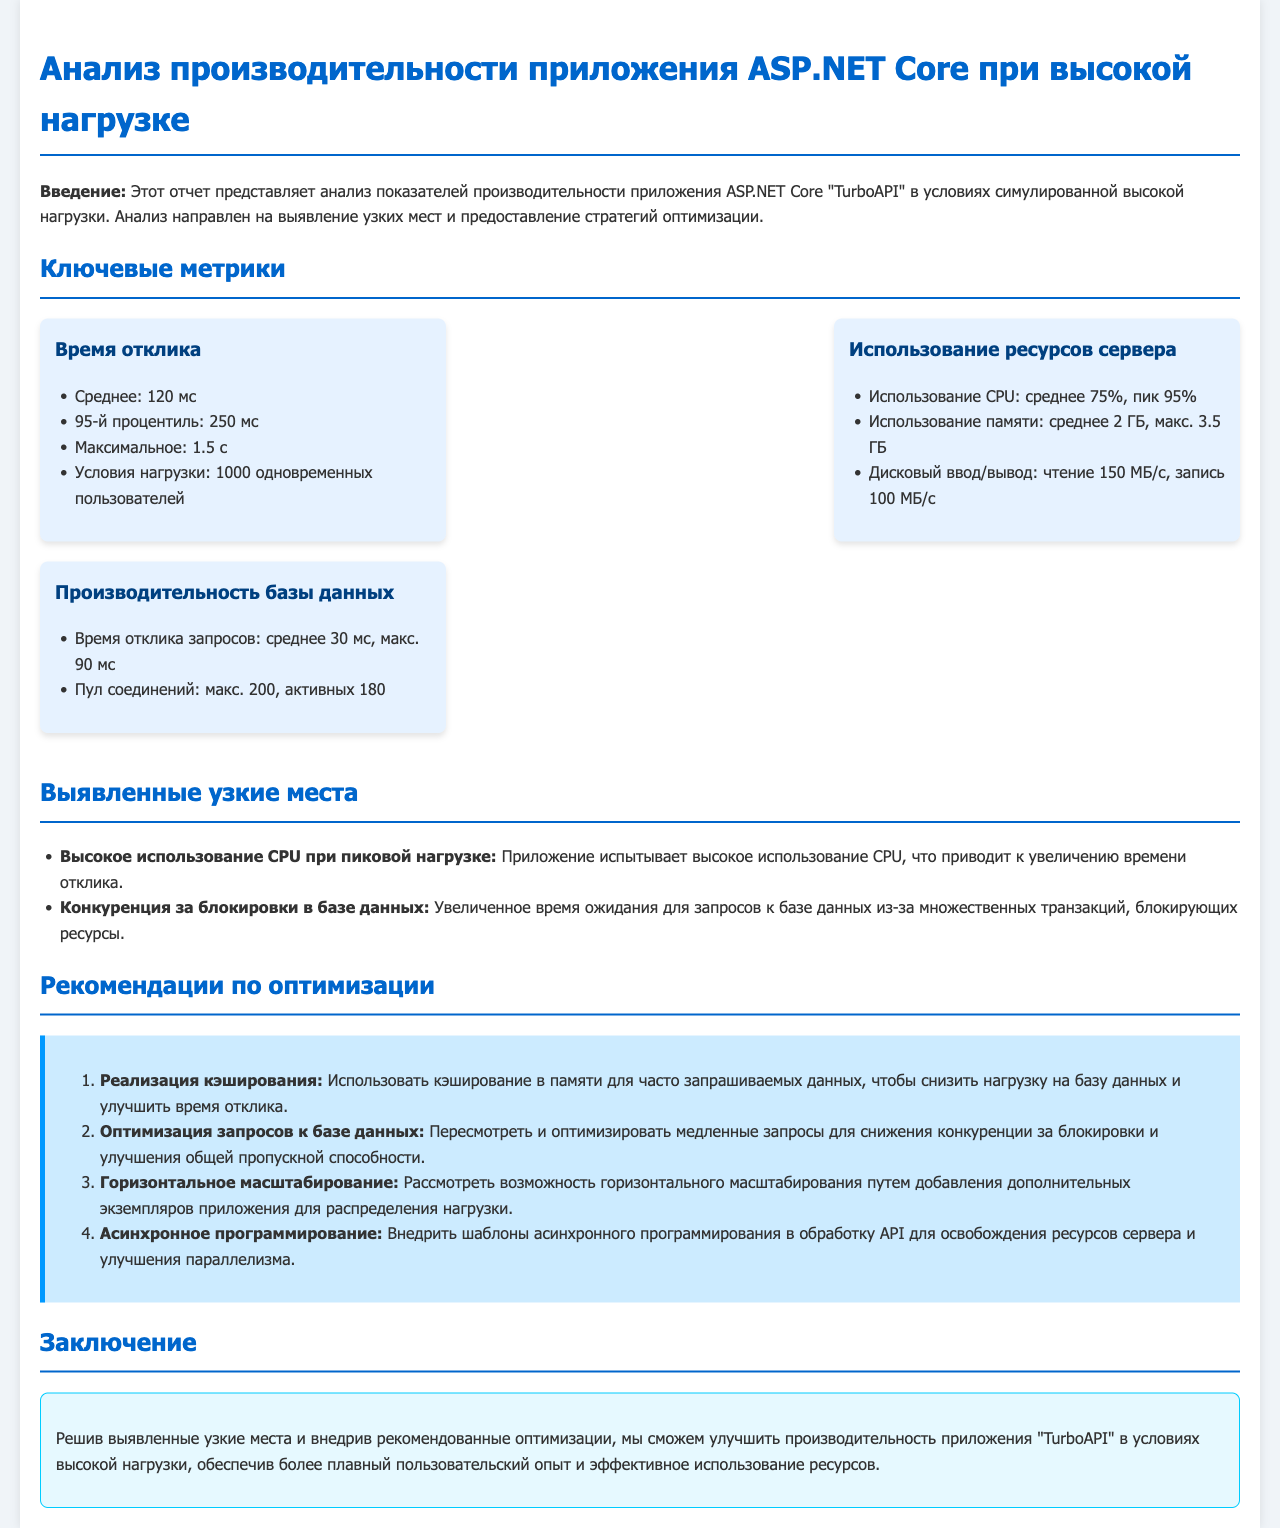что является средним временем отклика? Среднее время отклика указано в разделе ключевых метрик как 120 мс.
Answer: 120 мс какова максимальная загрузка CPU? Максимальная загрузка CPU указана в метриках как 95%.
Answer: 95% какой показатель использования памяти в максимальном состоянии? Максимальное использование памяти указано как 3.5 ГБ.
Answer: 3.5 ГБ что рекомендуется для снижения нагрузки на базу данных? В разделе рекомендаций указано, что для снижения нагрузки на базу данных следует использовать кэширование в памяти.
Answer: кэширование в памяти какова максимальная активность пула соединений с базой данных? Максимальная активность пула соединений указана как 200.
Answer: 200 